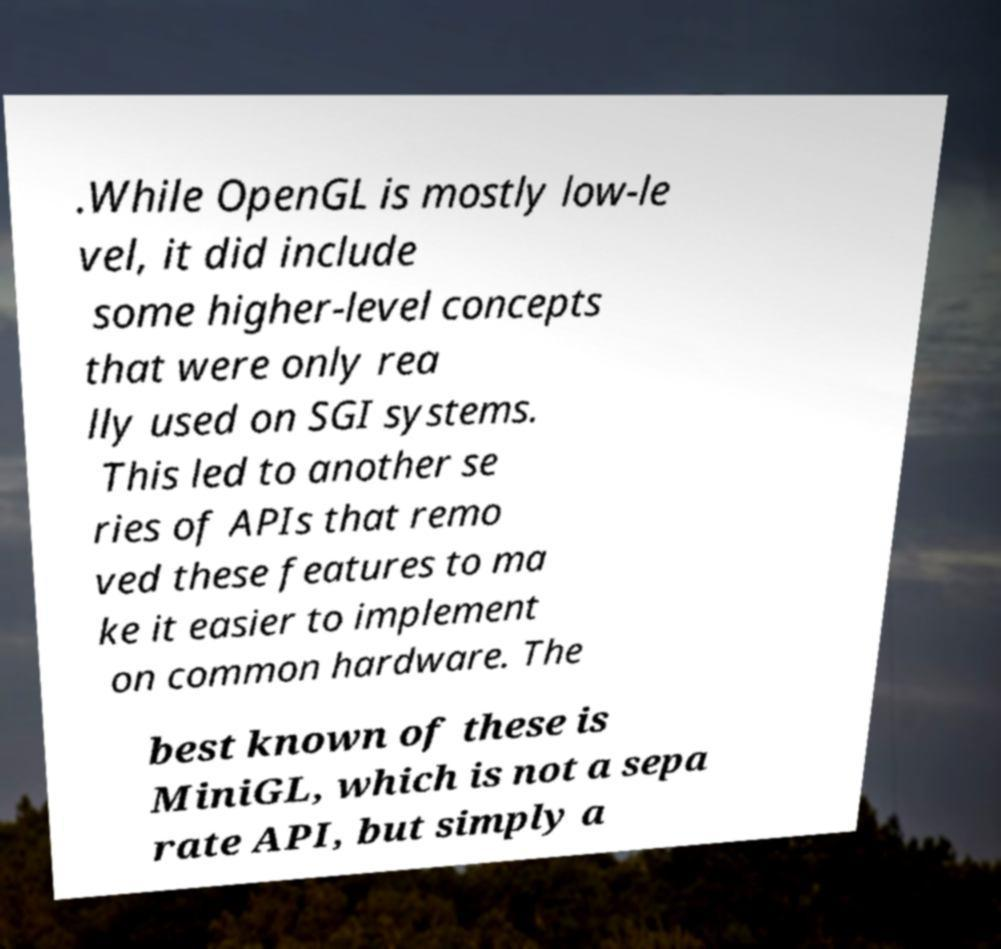I need the written content from this picture converted into text. Can you do that? .While OpenGL is mostly low-le vel, it did include some higher-level concepts that were only rea lly used on SGI systems. This led to another se ries of APIs that remo ved these features to ma ke it easier to implement on common hardware. The best known of these is MiniGL, which is not a sepa rate API, but simply a 